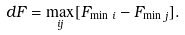Convert formula to latex. <formula><loc_0><loc_0><loc_500><loc_500>d F = \max _ { i j } [ F _ { \min \, i } - F _ { \min \, j } ] .</formula> 